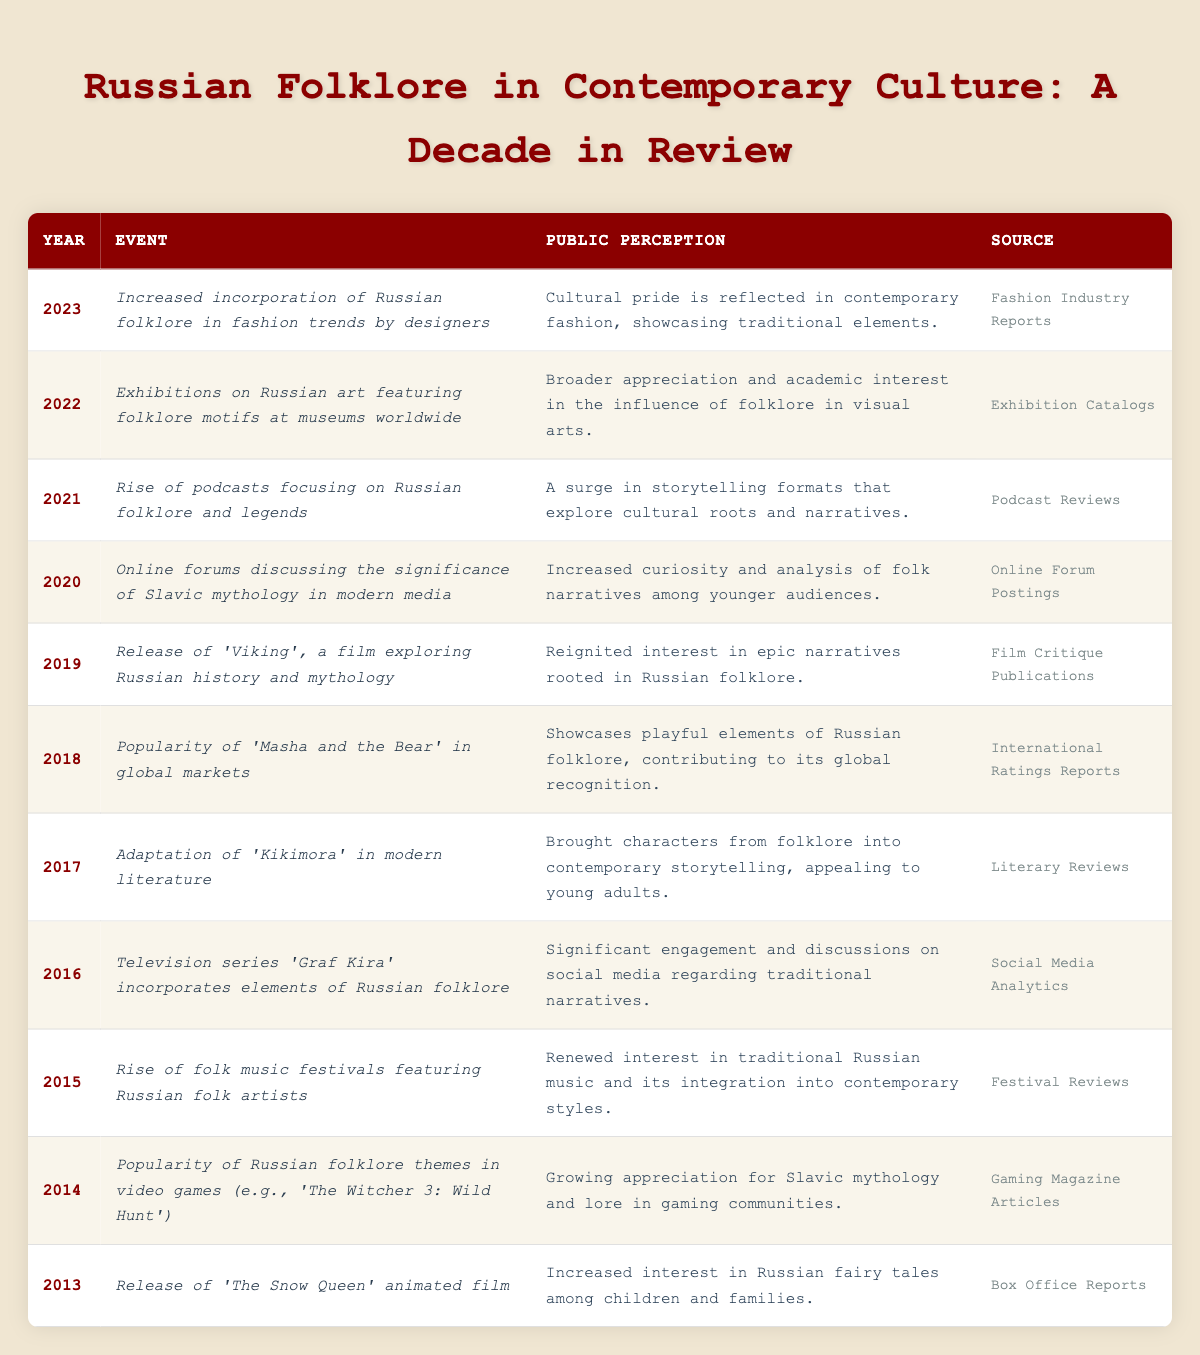What event in 2021 marked a rise in interest in Russian folklore? The event in 2021 was the rise of podcasts focusing on Russian folklore and legends, as listed in the table.
Answer: Podcasts focusing on folklore Which year saw increased interest in Russian fairy tales among children? The table indicates that in 2013, the release of 'The Snow Queen' animated film increased interest in Russian fairy tales among children and families.
Answer: 2013 In how many years was Russian folklore discussed in online forums? The table has one entry for online forums discussing the significance of Slavic mythology, which happened in 2020. Therefore, it was one year.
Answer: 1 year What percentage of events listed in the table are related to visual arts exhibitions? There are two events related to visual arts exhibitions (2022 exhibitions on Russian art). The total number of events is 11. Thus, (2/11) * 100 = 18.18%.
Answer: 18.18% Were any events in the table held in non-media forms, like music festivals or art exhibitions? Yes, the table includes a rise of folk music festivals in 2015 and exhibitions on Russian art in 2022, indicating engagement beyond media.
Answer: Yes What was the overall trend of public perception of Russian folklore in popular culture from 2013 to 2023? The data shows a consistent increase in public interest and appreciation for Russian folklore across various media including films, literature, music, and fashion over the decade.
Answer: Overall increasing trend Which year had the highest record of engagement on social media about traditional narratives? The year 2016, marked by the television series 'Graf Kira' incorporating elements of Russian folklore, showed significant engagement and discussions on social media.
Answer: 2016 How many events in the table directly related to modern literature adaptations? There is one event specifically related to modern literature adaptations, which is the adaptation of 'Kikimora' in 2017.
Answer: 1 event What is the key theme for the year 2015 regarding Russian folklore? The key theme for 2015 was the rise of folk music festivals featuring Russian folk artists, indicating a renewed interest in traditional music.
Answer: Folk music festivals How many mentions of Russian folklore were linked to gaming? There is one mention of Russian folklore related to gaming, which occurred in 2014 with the popularity of themes in video games.
Answer: 1 mention Which event highlighted the crossover of folklore into global markets? The event in 2018 concerning the popularity of 'Masha and the Bear' showcased playful elements of Russian folklore and contributed to its global recognition.
Answer: 'Masha and the Bear' in 2018 